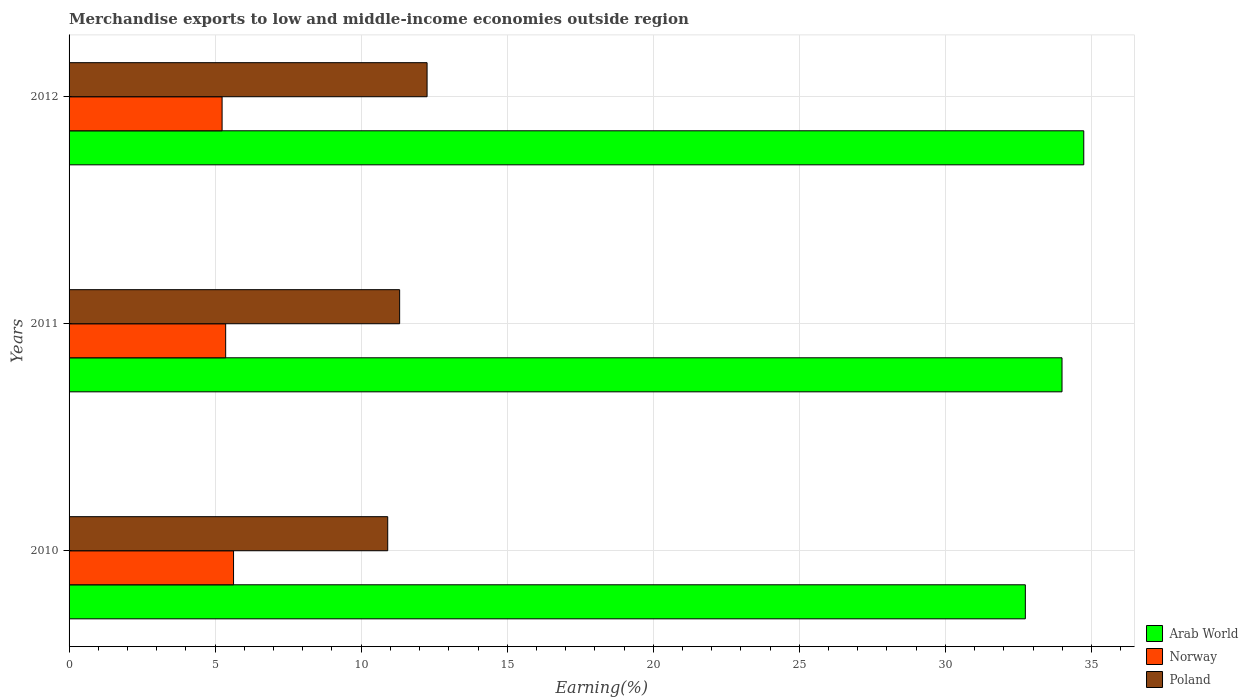How many different coloured bars are there?
Offer a terse response. 3. How many groups of bars are there?
Your response must be concise. 3. Are the number of bars per tick equal to the number of legend labels?
Your answer should be very brief. Yes. What is the label of the 2nd group of bars from the top?
Offer a very short reply. 2011. What is the percentage of amount earned from merchandise exports in Norway in 2010?
Provide a succinct answer. 5.63. Across all years, what is the maximum percentage of amount earned from merchandise exports in Norway?
Keep it short and to the point. 5.63. Across all years, what is the minimum percentage of amount earned from merchandise exports in Arab World?
Keep it short and to the point. 32.74. What is the total percentage of amount earned from merchandise exports in Poland in the graph?
Give a very brief answer. 34.48. What is the difference between the percentage of amount earned from merchandise exports in Arab World in 2011 and that in 2012?
Keep it short and to the point. -0.74. What is the difference between the percentage of amount earned from merchandise exports in Poland in 2010 and the percentage of amount earned from merchandise exports in Norway in 2012?
Your answer should be compact. 5.67. What is the average percentage of amount earned from merchandise exports in Poland per year?
Give a very brief answer. 11.49. In the year 2011, what is the difference between the percentage of amount earned from merchandise exports in Arab World and percentage of amount earned from merchandise exports in Norway?
Make the answer very short. 28.63. What is the ratio of the percentage of amount earned from merchandise exports in Norway in 2010 to that in 2011?
Your answer should be very brief. 1.05. Is the difference between the percentage of amount earned from merchandise exports in Arab World in 2010 and 2011 greater than the difference between the percentage of amount earned from merchandise exports in Norway in 2010 and 2011?
Make the answer very short. No. What is the difference between the highest and the second highest percentage of amount earned from merchandise exports in Norway?
Ensure brevity in your answer.  0.27. What is the difference between the highest and the lowest percentage of amount earned from merchandise exports in Arab World?
Make the answer very short. 2. What does the 3rd bar from the top in 2010 represents?
Keep it short and to the point. Arab World. What does the 3rd bar from the bottom in 2010 represents?
Your answer should be compact. Poland. Is it the case that in every year, the sum of the percentage of amount earned from merchandise exports in Norway and percentage of amount earned from merchandise exports in Poland is greater than the percentage of amount earned from merchandise exports in Arab World?
Provide a succinct answer. No. How many bars are there?
Your answer should be compact. 9. How many years are there in the graph?
Provide a succinct answer. 3. Are the values on the major ticks of X-axis written in scientific E-notation?
Offer a terse response. No. What is the title of the graph?
Your answer should be compact. Merchandise exports to low and middle-income economies outside region. What is the label or title of the X-axis?
Make the answer very short. Earning(%). What is the label or title of the Y-axis?
Ensure brevity in your answer.  Years. What is the Earning(%) of Arab World in 2010?
Make the answer very short. 32.74. What is the Earning(%) of Norway in 2010?
Your answer should be very brief. 5.63. What is the Earning(%) of Poland in 2010?
Provide a short and direct response. 10.91. What is the Earning(%) of Arab World in 2011?
Your response must be concise. 33.99. What is the Earning(%) in Norway in 2011?
Your response must be concise. 5.36. What is the Earning(%) of Poland in 2011?
Provide a succinct answer. 11.32. What is the Earning(%) in Arab World in 2012?
Provide a short and direct response. 34.74. What is the Earning(%) of Norway in 2012?
Offer a very short reply. 5.24. What is the Earning(%) of Poland in 2012?
Your response must be concise. 12.26. Across all years, what is the maximum Earning(%) in Arab World?
Ensure brevity in your answer.  34.74. Across all years, what is the maximum Earning(%) of Norway?
Ensure brevity in your answer.  5.63. Across all years, what is the maximum Earning(%) in Poland?
Keep it short and to the point. 12.26. Across all years, what is the minimum Earning(%) in Arab World?
Give a very brief answer. 32.74. Across all years, what is the minimum Earning(%) in Norway?
Give a very brief answer. 5.24. Across all years, what is the minimum Earning(%) in Poland?
Make the answer very short. 10.91. What is the total Earning(%) in Arab World in the graph?
Offer a terse response. 101.47. What is the total Earning(%) of Norway in the graph?
Provide a short and direct response. 16.23. What is the total Earning(%) of Poland in the graph?
Ensure brevity in your answer.  34.48. What is the difference between the Earning(%) in Arab World in 2010 and that in 2011?
Your answer should be compact. -1.26. What is the difference between the Earning(%) of Norway in 2010 and that in 2011?
Keep it short and to the point. 0.27. What is the difference between the Earning(%) in Poland in 2010 and that in 2011?
Offer a very short reply. -0.41. What is the difference between the Earning(%) of Arab World in 2010 and that in 2012?
Ensure brevity in your answer.  -2. What is the difference between the Earning(%) of Norway in 2010 and that in 2012?
Offer a terse response. 0.39. What is the difference between the Earning(%) in Poland in 2010 and that in 2012?
Make the answer very short. -1.35. What is the difference between the Earning(%) in Arab World in 2011 and that in 2012?
Your answer should be compact. -0.74. What is the difference between the Earning(%) in Norway in 2011 and that in 2012?
Provide a succinct answer. 0.12. What is the difference between the Earning(%) of Poland in 2011 and that in 2012?
Provide a short and direct response. -0.94. What is the difference between the Earning(%) in Arab World in 2010 and the Earning(%) in Norway in 2011?
Make the answer very short. 27.38. What is the difference between the Earning(%) in Arab World in 2010 and the Earning(%) in Poland in 2011?
Your answer should be compact. 21.42. What is the difference between the Earning(%) of Norway in 2010 and the Earning(%) of Poland in 2011?
Offer a terse response. -5.69. What is the difference between the Earning(%) in Arab World in 2010 and the Earning(%) in Norway in 2012?
Your answer should be compact. 27.5. What is the difference between the Earning(%) in Arab World in 2010 and the Earning(%) in Poland in 2012?
Make the answer very short. 20.48. What is the difference between the Earning(%) of Norway in 2010 and the Earning(%) of Poland in 2012?
Give a very brief answer. -6.62. What is the difference between the Earning(%) in Arab World in 2011 and the Earning(%) in Norway in 2012?
Your answer should be compact. 28.75. What is the difference between the Earning(%) in Arab World in 2011 and the Earning(%) in Poland in 2012?
Provide a succinct answer. 21.74. What is the difference between the Earning(%) in Norway in 2011 and the Earning(%) in Poland in 2012?
Make the answer very short. -6.89. What is the average Earning(%) of Arab World per year?
Your answer should be compact. 33.82. What is the average Earning(%) of Norway per year?
Keep it short and to the point. 5.41. What is the average Earning(%) of Poland per year?
Your answer should be compact. 11.49. In the year 2010, what is the difference between the Earning(%) in Arab World and Earning(%) in Norway?
Offer a very short reply. 27.11. In the year 2010, what is the difference between the Earning(%) of Arab World and Earning(%) of Poland?
Your answer should be compact. 21.83. In the year 2010, what is the difference between the Earning(%) of Norway and Earning(%) of Poland?
Make the answer very short. -5.28. In the year 2011, what is the difference between the Earning(%) of Arab World and Earning(%) of Norway?
Make the answer very short. 28.63. In the year 2011, what is the difference between the Earning(%) in Arab World and Earning(%) in Poland?
Keep it short and to the point. 22.68. In the year 2011, what is the difference between the Earning(%) of Norway and Earning(%) of Poland?
Your answer should be very brief. -5.96. In the year 2012, what is the difference between the Earning(%) in Arab World and Earning(%) in Norway?
Provide a short and direct response. 29.5. In the year 2012, what is the difference between the Earning(%) of Arab World and Earning(%) of Poland?
Your response must be concise. 22.48. In the year 2012, what is the difference between the Earning(%) in Norway and Earning(%) in Poland?
Ensure brevity in your answer.  -7.02. What is the ratio of the Earning(%) of Arab World in 2010 to that in 2011?
Give a very brief answer. 0.96. What is the ratio of the Earning(%) in Norway in 2010 to that in 2011?
Your response must be concise. 1.05. What is the ratio of the Earning(%) in Poland in 2010 to that in 2011?
Your response must be concise. 0.96. What is the ratio of the Earning(%) in Arab World in 2010 to that in 2012?
Make the answer very short. 0.94. What is the ratio of the Earning(%) in Norway in 2010 to that in 2012?
Ensure brevity in your answer.  1.07. What is the ratio of the Earning(%) of Poland in 2010 to that in 2012?
Offer a very short reply. 0.89. What is the ratio of the Earning(%) of Arab World in 2011 to that in 2012?
Your answer should be compact. 0.98. What is the ratio of the Earning(%) of Norway in 2011 to that in 2012?
Your answer should be very brief. 1.02. What is the ratio of the Earning(%) of Poland in 2011 to that in 2012?
Offer a very short reply. 0.92. What is the difference between the highest and the second highest Earning(%) in Arab World?
Keep it short and to the point. 0.74. What is the difference between the highest and the second highest Earning(%) of Norway?
Your response must be concise. 0.27. What is the difference between the highest and the second highest Earning(%) in Poland?
Offer a very short reply. 0.94. What is the difference between the highest and the lowest Earning(%) in Arab World?
Ensure brevity in your answer.  2. What is the difference between the highest and the lowest Earning(%) in Norway?
Keep it short and to the point. 0.39. What is the difference between the highest and the lowest Earning(%) in Poland?
Offer a terse response. 1.35. 